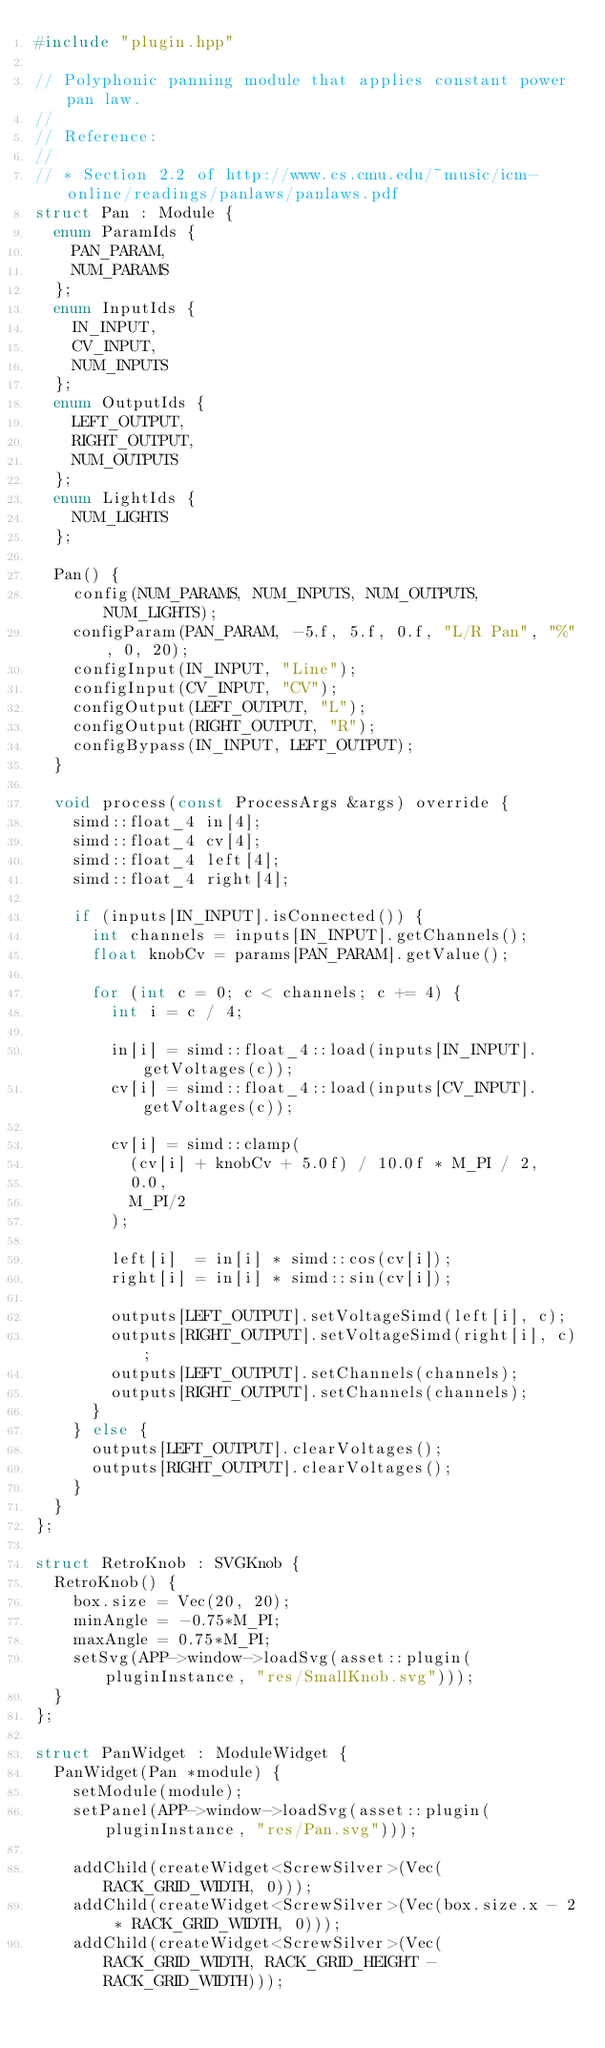<code> <loc_0><loc_0><loc_500><loc_500><_C++_>#include "plugin.hpp"

// Polyphonic panning module that applies constant power pan law.
//
// Reference:
//
// * Section 2.2 of http://www.cs.cmu.edu/~music/icm-online/readings/panlaws/panlaws.pdf
struct Pan : Module {
	enum ParamIds {
		PAN_PARAM,
		NUM_PARAMS
	};
	enum InputIds {
		IN_INPUT,
		CV_INPUT,
		NUM_INPUTS
	};
	enum OutputIds {
		LEFT_OUTPUT,
		RIGHT_OUTPUT,
		NUM_OUTPUTS
	};
	enum LightIds {
		NUM_LIGHTS
	};

	Pan() {
		config(NUM_PARAMS, NUM_INPUTS, NUM_OUTPUTS, NUM_LIGHTS);
		configParam(PAN_PARAM, -5.f, 5.f, 0.f, "L/R Pan", "%", 0, 20);
    configInput(IN_INPUT, "Line");
    configInput(CV_INPUT, "CV");
    configOutput(LEFT_OUTPUT, "L");
    configOutput(RIGHT_OUTPUT, "R");
    configBypass(IN_INPUT, LEFT_OUTPUT);
	}

	void process(const ProcessArgs &args) override {
    simd::float_4 in[4];
    simd::float_4 cv[4];
    simd::float_4 left[4];
    simd::float_4 right[4];

    if (inputs[IN_INPUT].isConnected()) {
      int channels = inputs[IN_INPUT].getChannels();
      float knobCv = params[PAN_PARAM].getValue();

      for (int c = 0; c < channels; c += 4) {
        int i = c / 4;

        in[i] = simd::float_4::load(inputs[IN_INPUT].getVoltages(c));
        cv[i] = simd::float_4::load(inputs[CV_INPUT].getVoltages(c));

        cv[i] = simd::clamp(
          (cv[i] + knobCv + 5.0f) / 10.0f * M_PI / 2,
          0.0,
          M_PI/2
        );

        left[i]  = in[i] * simd::cos(cv[i]);
        right[i] = in[i] * simd::sin(cv[i]);

        outputs[LEFT_OUTPUT].setVoltageSimd(left[i], c);
        outputs[RIGHT_OUTPUT].setVoltageSimd(right[i], c);
        outputs[LEFT_OUTPUT].setChannels(channels);
        outputs[RIGHT_OUTPUT].setChannels(channels);
      }
    } else {
      outputs[LEFT_OUTPUT].clearVoltages();
      outputs[RIGHT_OUTPUT].clearVoltages();
    }
	}
};

struct RetroKnob : SVGKnob {
	RetroKnob() {
		box.size = Vec(20, 20);
		minAngle = -0.75*M_PI;
		maxAngle = 0.75*M_PI;
		setSvg(APP->window->loadSvg(asset::plugin(pluginInstance, "res/SmallKnob.svg")));
	}
};

struct PanWidget : ModuleWidget {
	PanWidget(Pan *module) {
		setModule(module);
		setPanel(APP->window->loadSvg(asset::plugin(pluginInstance, "res/Pan.svg")));

		addChild(createWidget<ScrewSilver>(Vec(RACK_GRID_WIDTH, 0)));
		addChild(createWidget<ScrewSilver>(Vec(box.size.x - 2 * RACK_GRID_WIDTH, 0)));
		addChild(createWidget<ScrewSilver>(Vec(RACK_GRID_WIDTH, RACK_GRID_HEIGHT - RACK_GRID_WIDTH)));</code> 